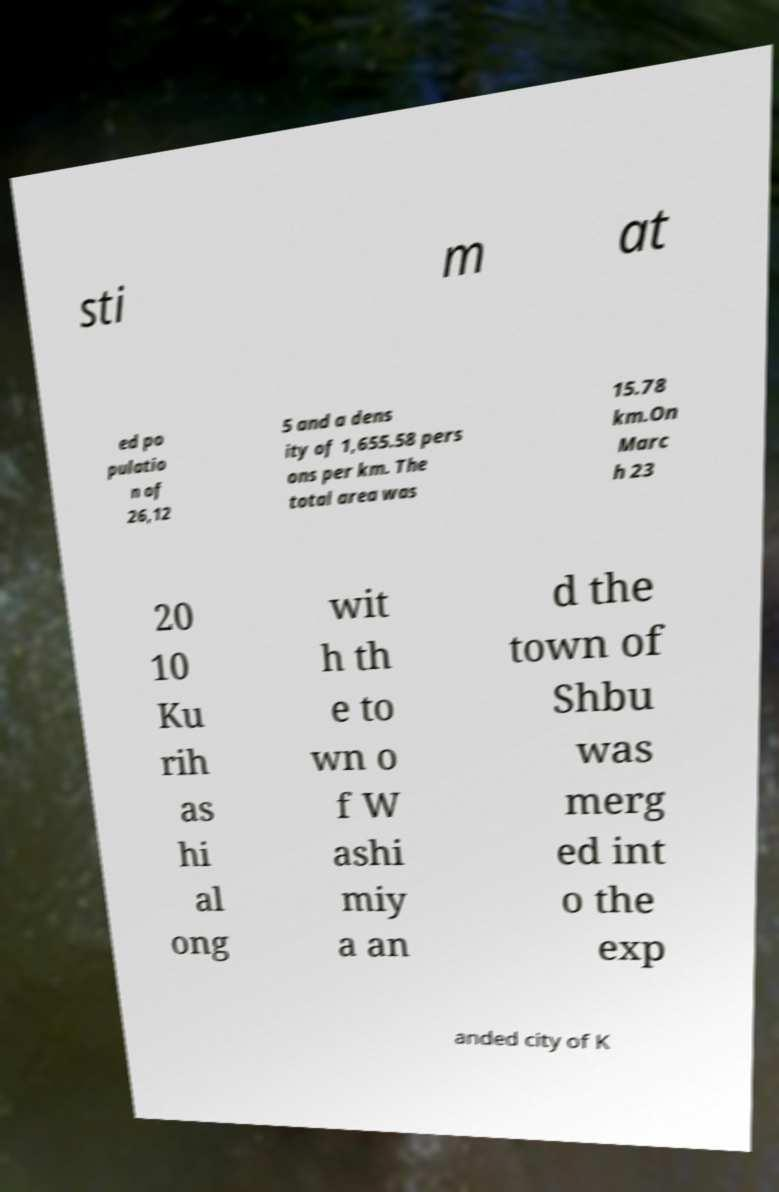Could you extract and type out the text from this image? sti m at ed po pulatio n of 26,12 5 and a dens ity of 1,655.58 pers ons per km. The total area was 15.78 km.On Marc h 23 20 10 Ku rih as hi al ong wit h th e to wn o f W ashi miy a an d the town of Shbu was merg ed int o the exp anded city of K 